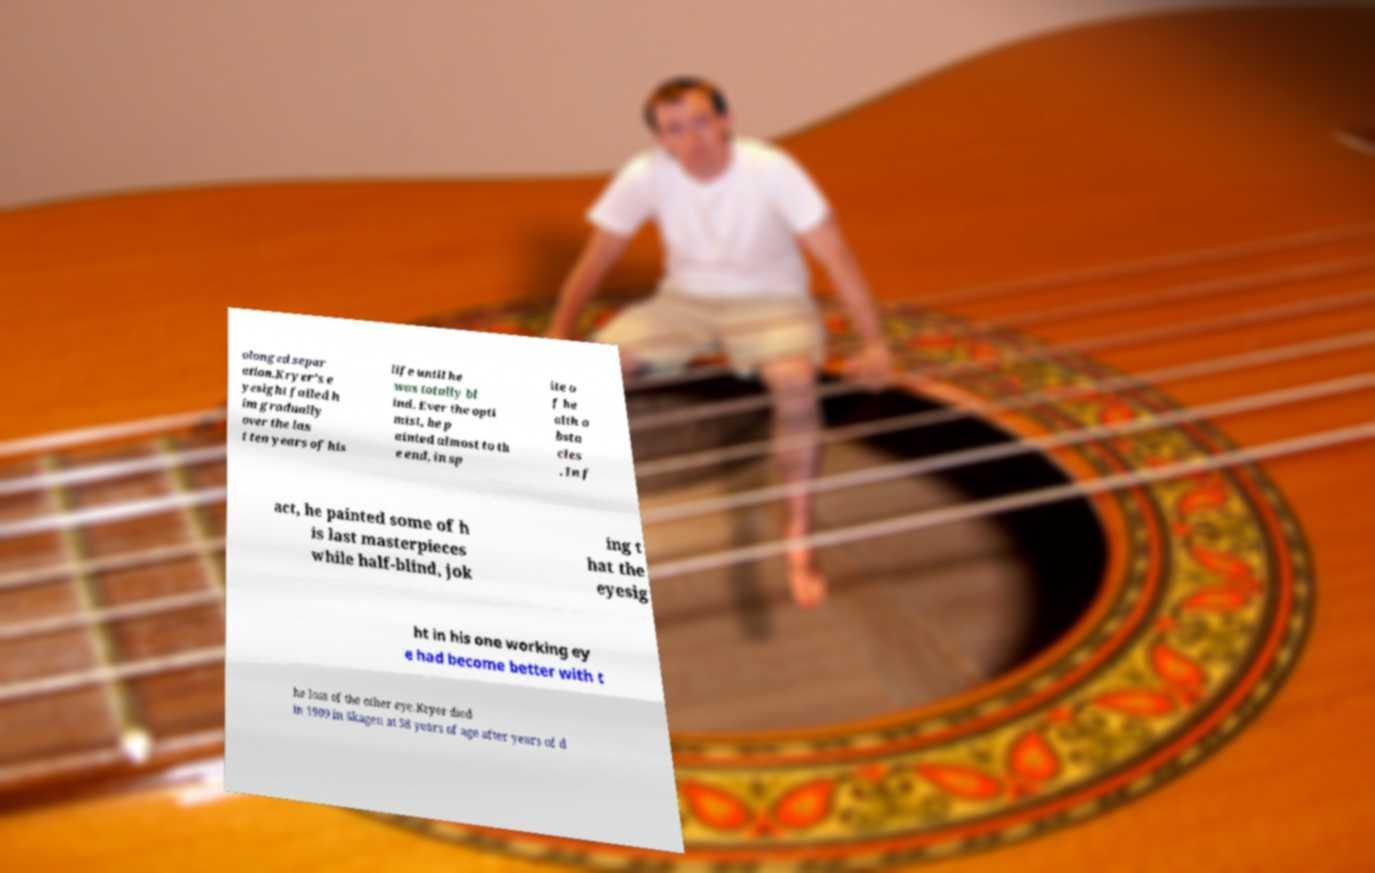Could you assist in decoding the text presented in this image and type it out clearly? olonged separ ation.Kryer's e yesight failed h im gradually over the las t ten years of his life until he was totally bl ind. Ever the opti mist, he p ainted almost to th e end, in sp ite o f he alth o bsta cles . In f act, he painted some of h is last masterpieces while half-blind, jok ing t hat the eyesig ht in his one working ey e had become better with t he loss of the other eye.Kryer died in 1909 in Skagen at 58 years of age after years of d 